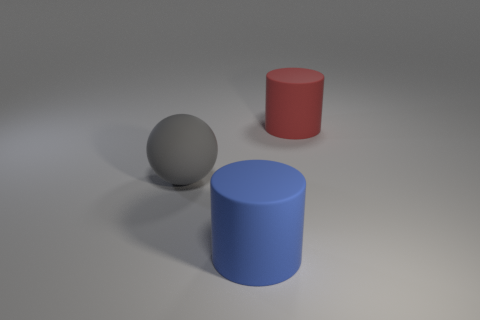What material is the big thing that is behind the gray object?
Provide a short and direct response. Rubber. What number of other things are the same size as the gray thing?
Provide a succinct answer. 2. Does the rubber sphere have the same size as the rubber object that is in front of the sphere?
Make the answer very short. Yes. What is the shape of the gray rubber object that is in front of the red cylinder right of the big cylinder that is in front of the big gray ball?
Ensure brevity in your answer.  Sphere. Are there fewer gray matte things than small cyan shiny balls?
Make the answer very short. No. There is a large gray matte object; are there any big red things in front of it?
Provide a short and direct response. No. What shape is the large object that is both in front of the red matte cylinder and on the right side of the gray rubber ball?
Provide a succinct answer. Cylinder. Is there a red rubber thing that has the same shape as the large gray matte thing?
Give a very brief answer. No. There is a matte object that is on the left side of the large blue thing; is it the same size as the rubber object right of the large blue rubber cylinder?
Make the answer very short. Yes. Are there more spheres than objects?
Offer a terse response. No. 